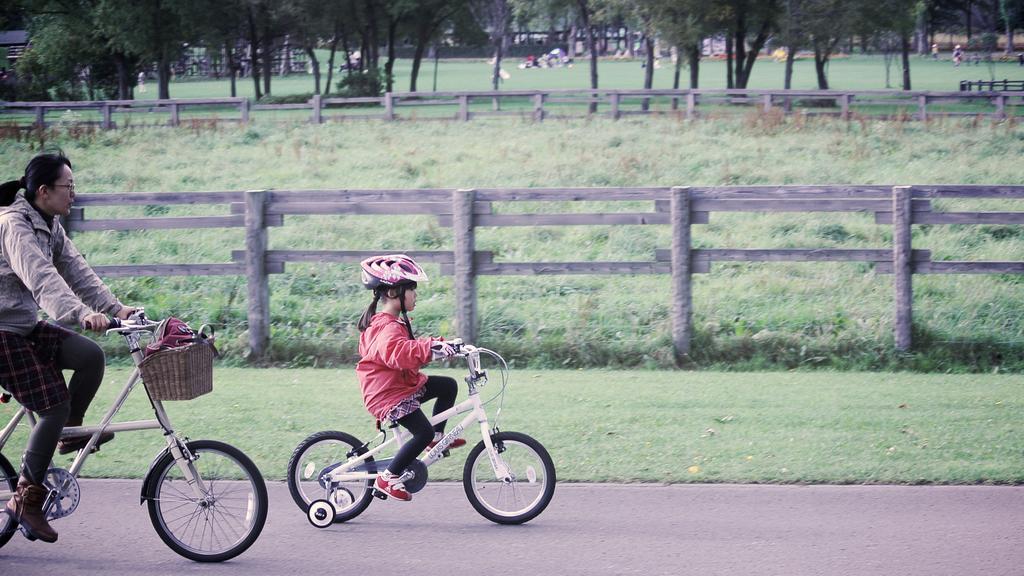Describe this image in one or two sentences. This picture might be taken from outside of the city. In this image, on the left side, we can see a woman riding a bicycle. In the middle of the image, we can see a girl riding a bicycle on the road. In the background, we can see wood fence, trees, a group of people. At the bottom, we can see some plants, grass and a road. 